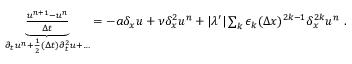Convert formula to latex. <formula><loc_0><loc_0><loc_500><loc_500>\begin{array} { r } { \underbrace { \frac { u ^ { n + 1 } - u ^ { n } } { \Delta t } } _ { \partial _ { t } u ^ { n } + \frac { 1 } { 2 } ( \Delta t ) \partial _ { t } ^ { 2 } u + \dots } = - a \delta _ { x } u + \nu \delta _ { x } ^ { 2 } u ^ { n } + | \lambda ^ { \prime } | \sum _ { k } \epsilon _ { k } ( \Delta x ) ^ { 2 k - 1 } \delta _ { x } ^ { 2 k } u ^ { n } \ . } \end{array}</formula> 